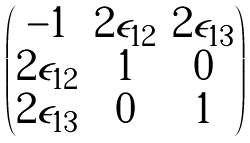<formula> <loc_0><loc_0><loc_500><loc_500>\begin{pmatrix} - 1 & 2 \epsilon _ { 1 2 } & 2 \epsilon _ { 1 3 } \\ 2 \epsilon _ { 1 2 } & 1 & 0 \\ 2 \epsilon _ { 1 3 } & 0 & 1 \end{pmatrix}</formula> 